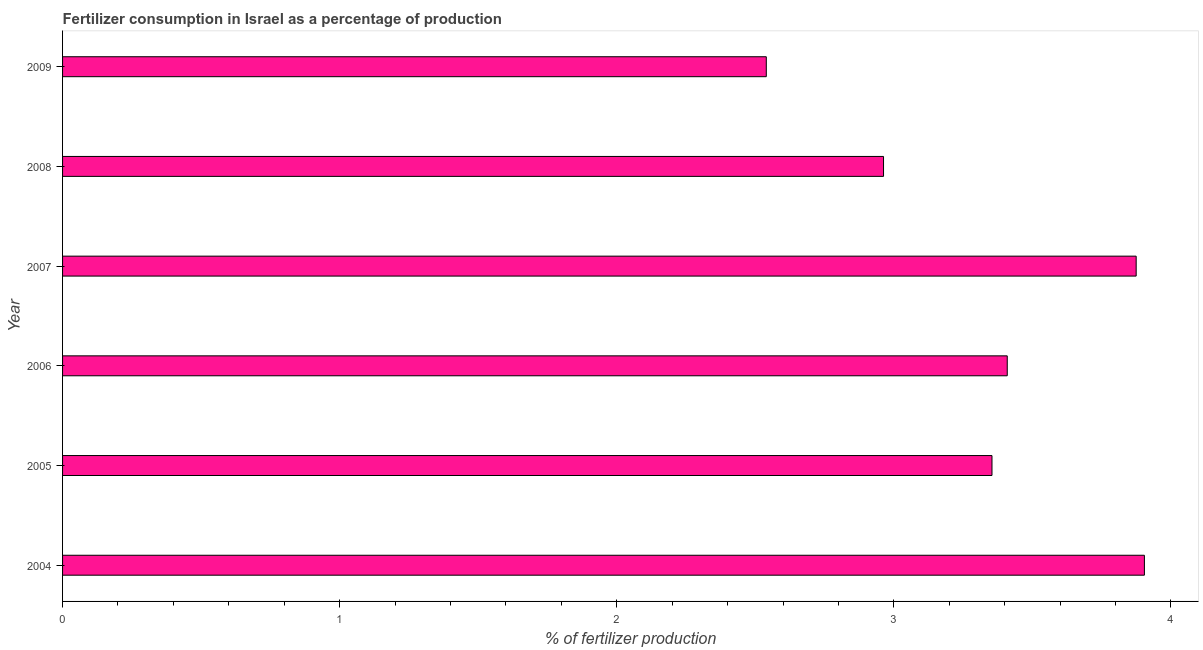Does the graph contain any zero values?
Provide a succinct answer. No. Does the graph contain grids?
Your answer should be compact. No. What is the title of the graph?
Keep it short and to the point. Fertilizer consumption in Israel as a percentage of production. What is the label or title of the X-axis?
Ensure brevity in your answer.  % of fertilizer production. What is the amount of fertilizer consumption in 2004?
Provide a succinct answer. 3.9. Across all years, what is the maximum amount of fertilizer consumption?
Keep it short and to the point. 3.9. Across all years, what is the minimum amount of fertilizer consumption?
Your answer should be compact. 2.54. In which year was the amount of fertilizer consumption maximum?
Provide a succinct answer. 2004. What is the sum of the amount of fertilizer consumption?
Provide a succinct answer. 20.04. What is the average amount of fertilizer consumption per year?
Offer a very short reply. 3.34. What is the median amount of fertilizer consumption?
Keep it short and to the point. 3.38. Do a majority of the years between 2006 and 2004 (inclusive) have amount of fertilizer consumption greater than 1.4 %?
Offer a terse response. Yes. Is the amount of fertilizer consumption in 2004 less than that in 2006?
Your answer should be compact. No. What is the difference between the highest and the second highest amount of fertilizer consumption?
Provide a short and direct response. 0.03. Is the sum of the amount of fertilizer consumption in 2007 and 2008 greater than the maximum amount of fertilizer consumption across all years?
Ensure brevity in your answer.  Yes. What is the difference between the highest and the lowest amount of fertilizer consumption?
Provide a succinct answer. 1.36. Are all the bars in the graph horizontal?
Offer a very short reply. Yes. What is the difference between two consecutive major ticks on the X-axis?
Your answer should be very brief. 1. Are the values on the major ticks of X-axis written in scientific E-notation?
Provide a succinct answer. No. What is the % of fertilizer production in 2004?
Offer a very short reply. 3.9. What is the % of fertilizer production in 2005?
Provide a succinct answer. 3.35. What is the % of fertilizer production in 2006?
Provide a succinct answer. 3.41. What is the % of fertilizer production in 2007?
Keep it short and to the point. 3.87. What is the % of fertilizer production in 2008?
Offer a terse response. 2.96. What is the % of fertilizer production of 2009?
Your response must be concise. 2.54. What is the difference between the % of fertilizer production in 2004 and 2005?
Your answer should be compact. 0.55. What is the difference between the % of fertilizer production in 2004 and 2006?
Offer a very short reply. 0.49. What is the difference between the % of fertilizer production in 2004 and 2007?
Offer a very short reply. 0.03. What is the difference between the % of fertilizer production in 2004 and 2008?
Your answer should be compact. 0.94. What is the difference between the % of fertilizer production in 2004 and 2009?
Keep it short and to the point. 1.36. What is the difference between the % of fertilizer production in 2005 and 2006?
Offer a very short reply. -0.06. What is the difference between the % of fertilizer production in 2005 and 2007?
Ensure brevity in your answer.  -0.52. What is the difference between the % of fertilizer production in 2005 and 2008?
Keep it short and to the point. 0.39. What is the difference between the % of fertilizer production in 2005 and 2009?
Ensure brevity in your answer.  0.81. What is the difference between the % of fertilizer production in 2006 and 2007?
Keep it short and to the point. -0.47. What is the difference between the % of fertilizer production in 2006 and 2008?
Give a very brief answer. 0.45. What is the difference between the % of fertilizer production in 2006 and 2009?
Give a very brief answer. 0.87. What is the difference between the % of fertilizer production in 2007 and 2008?
Keep it short and to the point. 0.91. What is the difference between the % of fertilizer production in 2007 and 2009?
Your response must be concise. 1.33. What is the difference between the % of fertilizer production in 2008 and 2009?
Provide a succinct answer. 0.42. What is the ratio of the % of fertilizer production in 2004 to that in 2005?
Keep it short and to the point. 1.16. What is the ratio of the % of fertilizer production in 2004 to that in 2006?
Make the answer very short. 1.15. What is the ratio of the % of fertilizer production in 2004 to that in 2008?
Keep it short and to the point. 1.32. What is the ratio of the % of fertilizer production in 2004 to that in 2009?
Provide a succinct answer. 1.54. What is the ratio of the % of fertilizer production in 2005 to that in 2007?
Offer a very short reply. 0.87. What is the ratio of the % of fertilizer production in 2005 to that in 2008?
Offer a terse response. 1.13. What is the ratio of the % of fertilizer production in 2005 to that in 2009?
Give a very brief answer. 1.32. What is the ratio of the % of fertilizer production in 2006 to that in 2008?
Offer a very short reply. 1.15. What is the ratio of the % of fertilizer production in 2006 to that in 2009?
Your answer should be very brief. 1.34. What is the ratio of the % of fertilizer production in 2007 to that in 2008?
Provide a succinct answer. 1.31. What is the ratio of the % of fertilizer production in 2007 to that in 2009?
Keep it short and to the point. 1.53. What is the ratio of the % of fertilizer production in 2008 to that in 2009?
Your answer should be very brief. 1.17. 